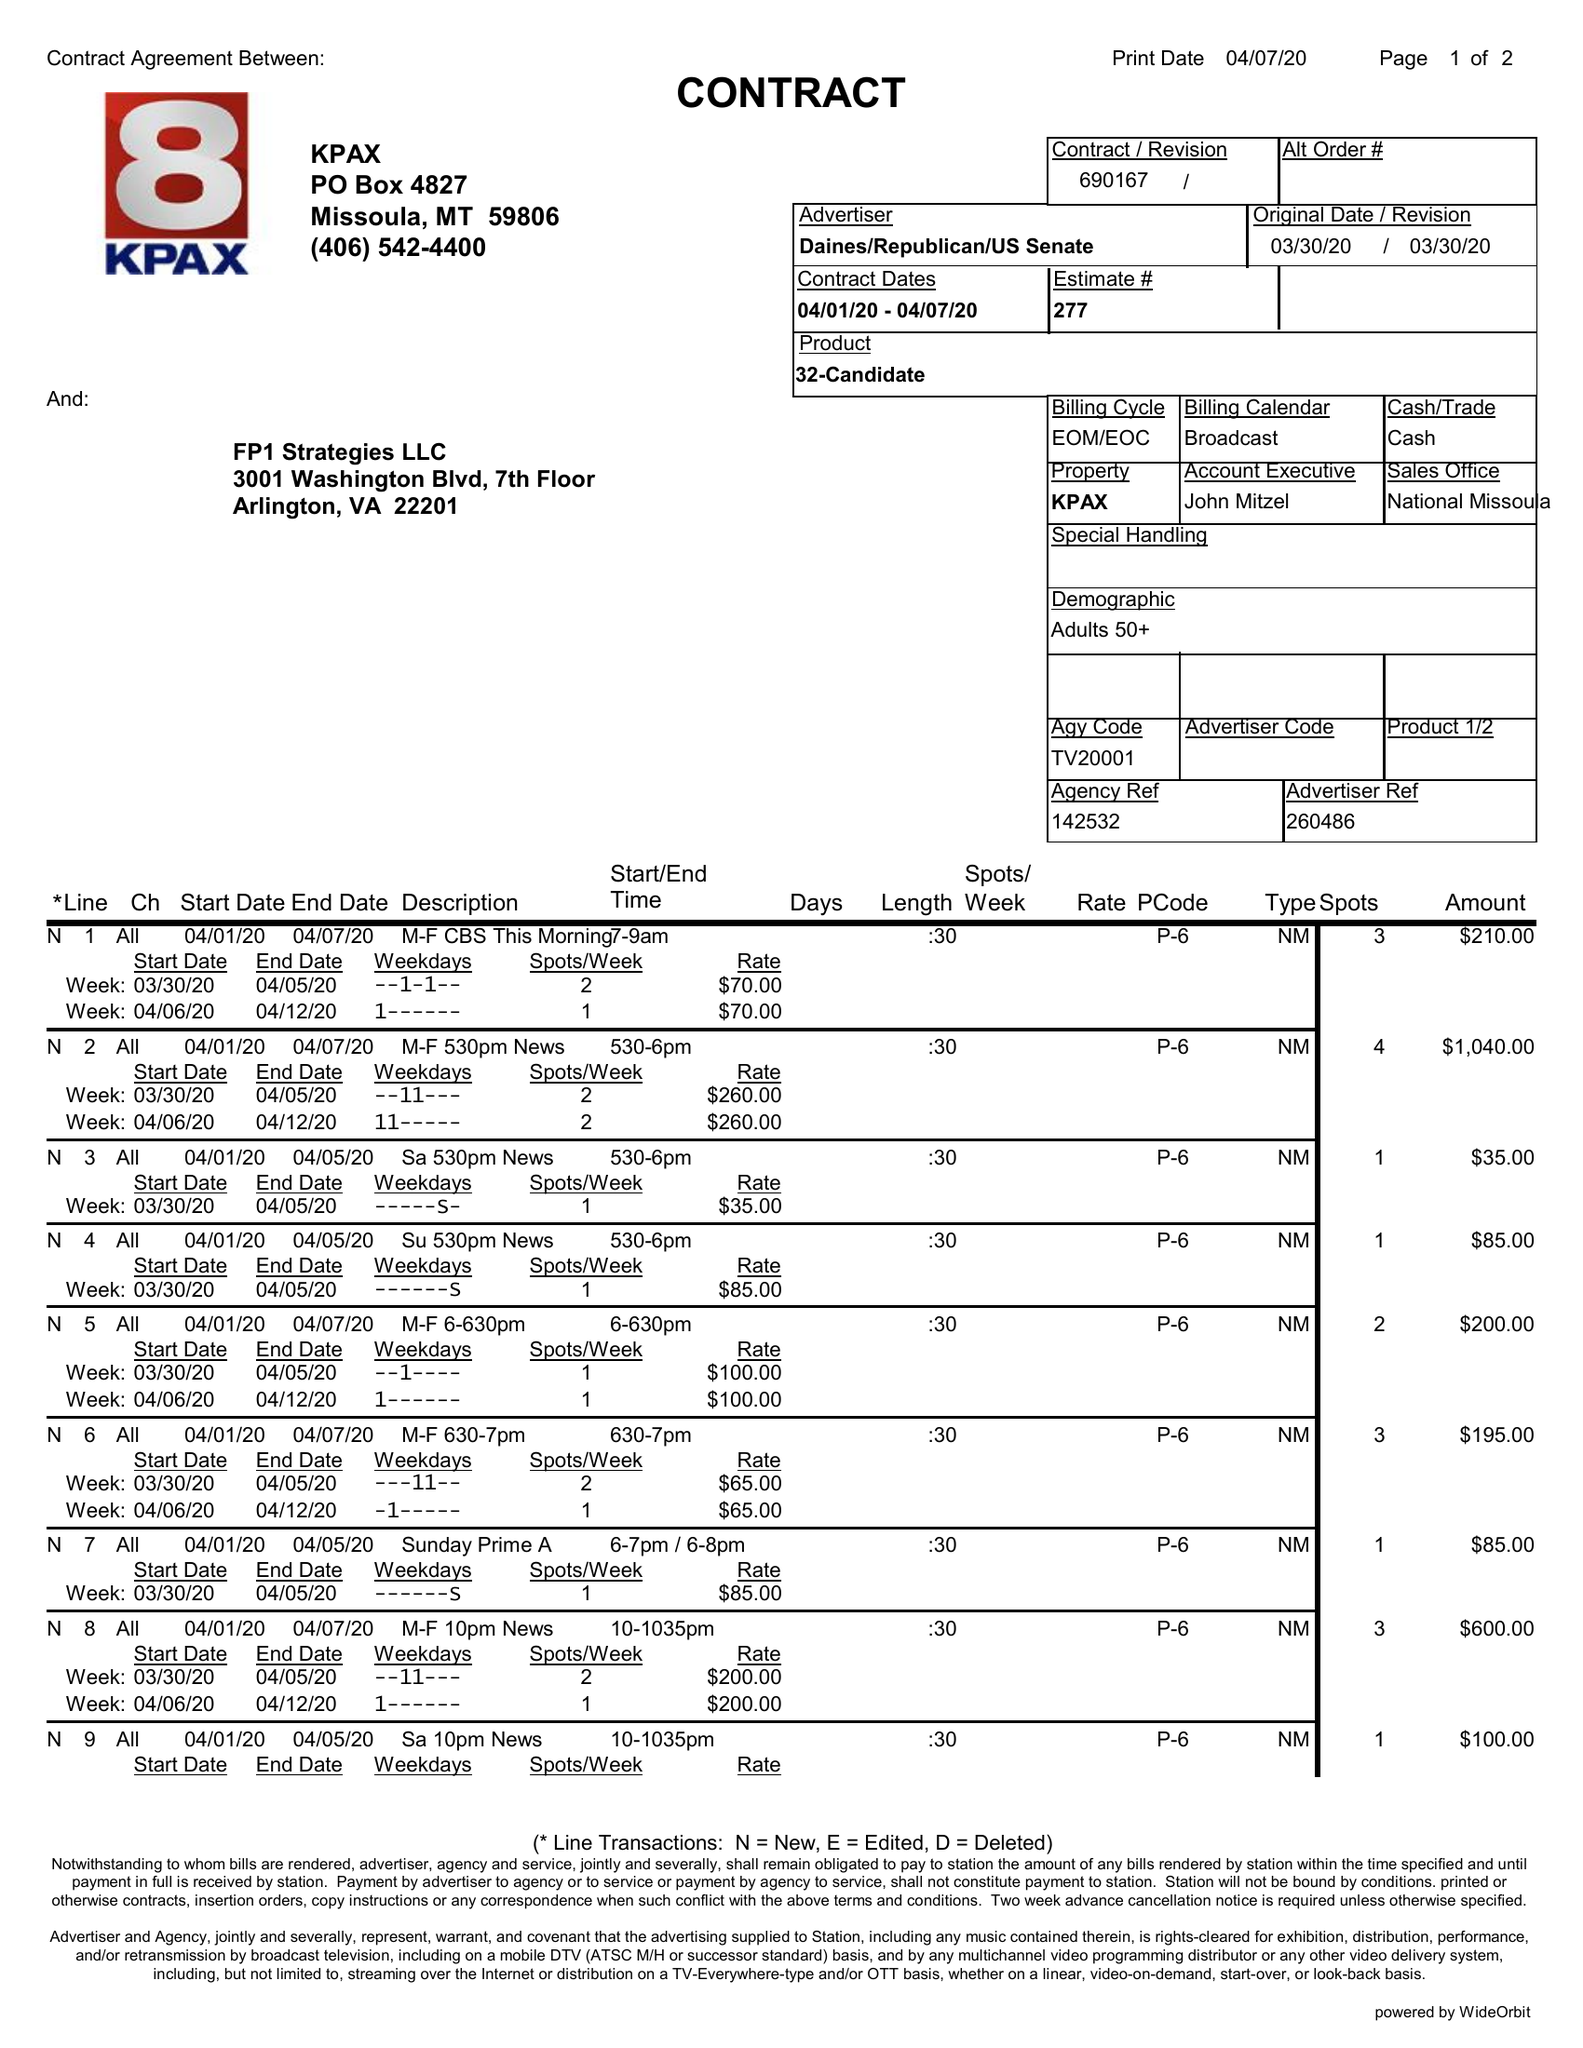What is the value for the gross_amount?
Answer the question using a single word or phrase. 2730.00 